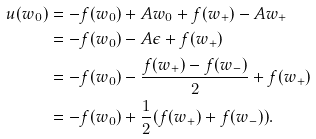<formula> <loc_0><loc_0><loc_500><loc_500>u ( w _ { 0 } ) & = - f ( w _ { 0 } ) + A w _ { 0 } + f ( w _ { + } ) - A w _ { + } \\ & = - f ( w _ { 0 } ) - A \epsilon + f ( w _ { + } ) \\ & = - f ( w _ { 0 } ) - \frac { f ( w _ { + } ) - f ( w _ { - } ) } { 2 } + f ( w _ { + } ) \\ & = - f ( w _ { 0 } ) + \frac { 1 } { 2 } ( f ( w _ { + } ) + f ( w _ { - } ) ) .</formula> 